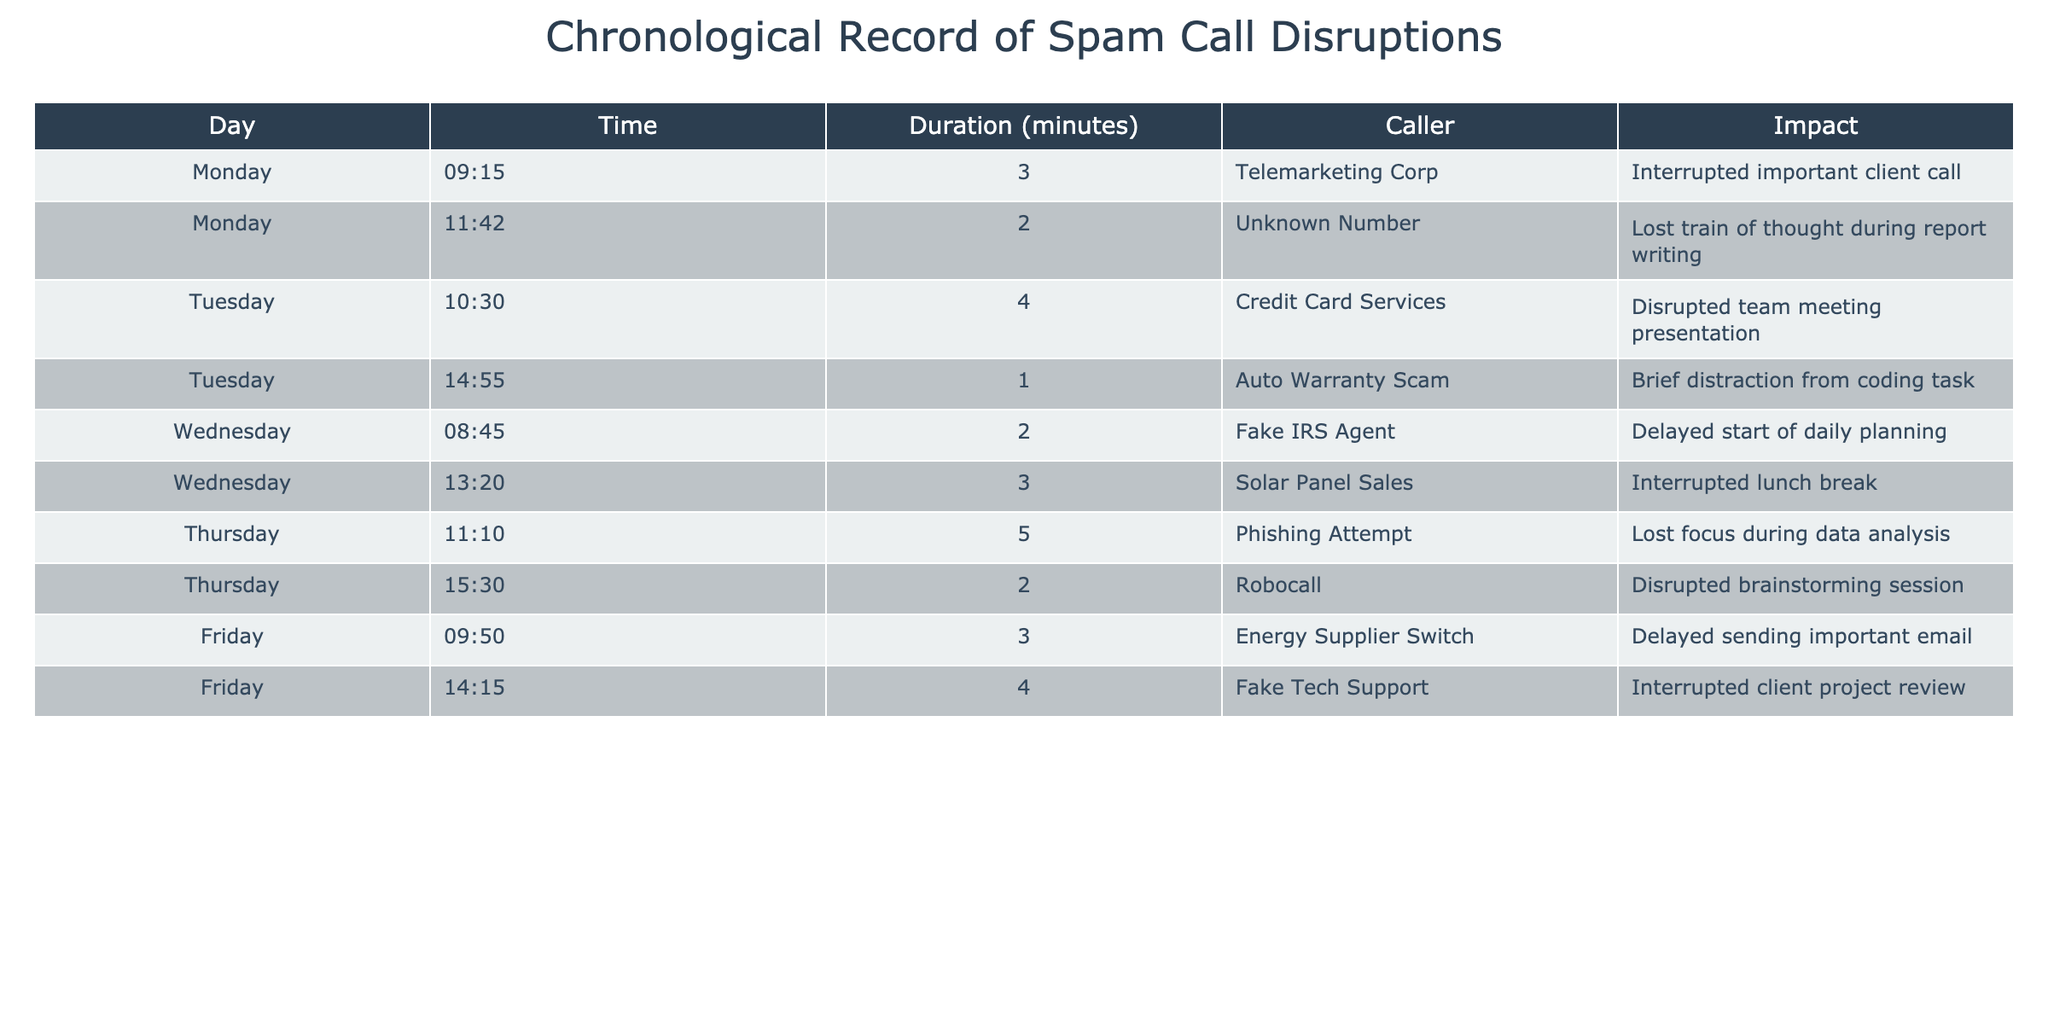What day did the longest disruption occur? The longest disruption is 5 minutes long, which happens on Thursday at 11:10. Therefore, the longest disruption occurred on Thursday.
Answer: Thursday What is the total duration of disruptions on Tuesday? Tuesday has two entries: a 4-minute disruption and a 1-minute disruption. Adding these gives 4 + 1 = 5 minutes.
Answer: 5 minutes Did any disruption occur during the lunch break on Wednesday? Yes, on Wednesday at 13:20, there was a 3-minute disruption caused by Solar Panel Sales, which qualifies as an interruption during lunch.
Answer: Yes Which caller disrupted the daily planning on Wednesday, and for how long? The daily planning on Wednesday was disrupted by the Fake IRS Agent for 2 minutes at 08:45.
Answer: Fake IRS Agent, 2 minutes What was the average duration of spam call disruptions throughout the week? First, we need to add up all the durations: 3 + 2 + 4 + 1 + 2 + 3 + 5 + 2 + 3 + 4 = 25 minutes. There are 10 disruptions in total, so the average is 25/10 = 2.5 minutes.
Answer: 2.5 minutes How many disruptions were caused by unknown or suspicious callers? The unknown or suspicious callers include: Telemarketing Corp, Unknown Number, Credit Card Services, Auto Warranty Scam, Fake IRS Agent, Solar Panel Sales, Phishing Attempt, Robocall, Energy Supplier Switch, and Fake Tech Support. All of the calls are from suspicious sources, totaling 10 disruptions.
Answer: 10 disruptions On which day was the fewest disruptions recorded, and what were they? The day with the fewest disruptions is Tuesday, with only two calls: Credit Card Services for 4 minutes and Auto Warranty Scam for 1 minute.
Answer: Tuesday, Credit Card Services for 4 minutes, Auto Warranty Scam for 1 minute What type of impact did the disruption from Robocall cause? The disruption by Robocall occurred during a brainstorming session, leading to lost focus.
Answer: Lost focus during brainstorming session 